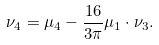<formula> <loc_0><loc_0><loc_500><loc_500>\nu _ { 4 } = \mu _ { 4 } - \frac { 1 6 } { 3 \pi } \mu _ { 1 } \cdot \nu _ { 3 } .</formula> 